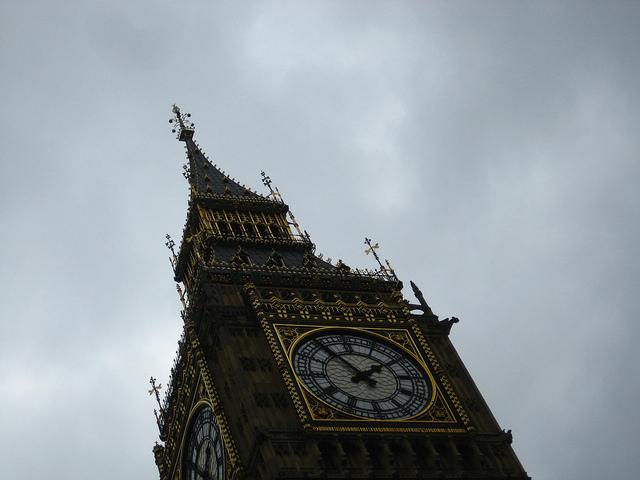What famous landmark is shown?
Be succinct. Big ben. What time is on the clock?
Keep it brief. 1:55. What is the weather like?
Answer briefly. Cloudy. Is it sunny?
Short answer required. No. What time will in be five minutes from now?
Write a very short answer. 2:00. What country is this clock located in?
Answer briefly. England. 